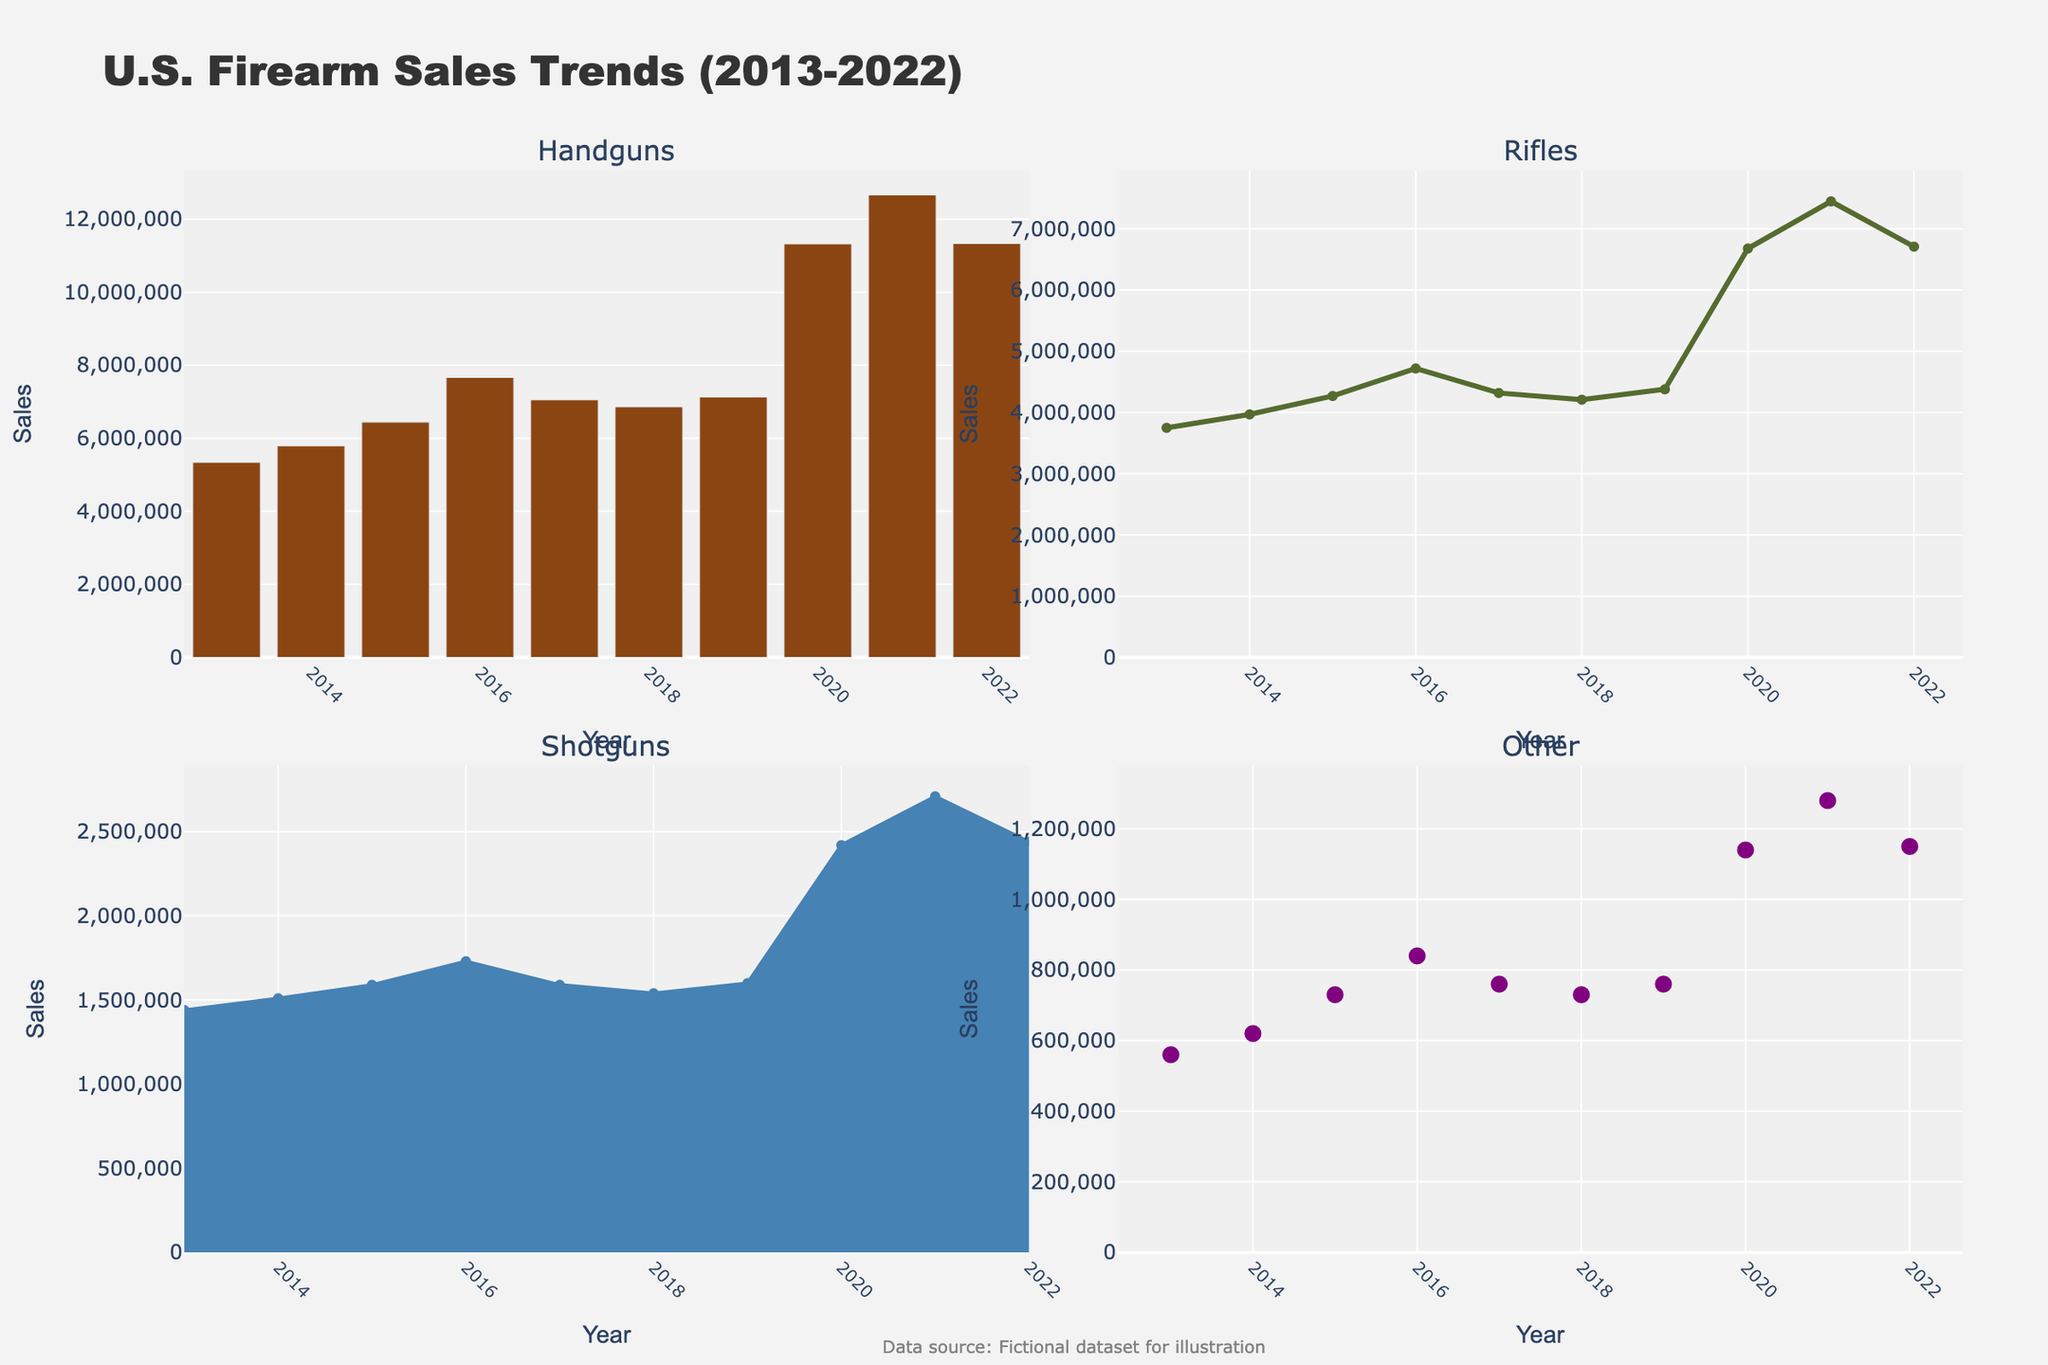What is the highest number of Mountain Bikes sold in any given year? Looking at the Mountain Bikes subplot, we see that the maximum sales occur in 2020, with 4500 units sold.
Answer: 4500 What trend can be observed in the sales of City Bikes from 1990 to 2020? Observing the City Bikes subplot, sales show a steady increase over the years from 1990 (3500) to 2020 (6500). The trend clearly indicates growing popularity of City Bikes.
Answer: Steady increase Which type of bike had the highest sales in the year 1995? In the year 1995, the sales data for Road, Mountain, and City Bikes are 1500, 1800, and 4000 respectively. Clearly, City Bikes had the highest sales.
Answer: City Bikes How do Road Bikes sales in 2020 compare to their sales in 1990? In 2020, Road Bikes sales are 1000, while in 1990, it was 1200. Therefore, Road Bikes sales decreased over this period.
Answer: Decreased What is the average sales of Mountain Bikes between 1990 and 2020? The sales for Mountain Bikes across the years are: 800, 1800, 2500, 3200, 3800, 4200, and 4500. Summing these gives 20800. Dividing by 7 (the number of data points) gives an average of 2971.43.
Answer: 2971.43 How do the sales trends of Road Bikes and Mountain Bikes compare over the three decades? Road Bikes sales show a general decline from 1990 (1200) to 2020 (1000). In contrast, Mountain Bikes sales show a steady increase from 1990 (800) to 2020 (4500). This reflects growing popularity of Mountain Bikes over time compared to Road Bikes.
Answer: Road Bikes declined, Mountain Bikes increased In which year did City Bikes see a sales pass of the 5000 units mark? Observing the City Bikes subplot, sales hit 5000 units in the year 2005 and continued to rise afterward.
Answer: 2005 What is the difference in Road Bikes sales between the peak year and the lowest year? The peak year for Road Bikes is 2000 with 1800 units sold, and the lowest year is 2020 with 1000 units sold. The difference is 1800 - 100 = 800.
Answer: 800 What's the relative growth in City Bikes sales from 1990 to 2020? In 1990, City Bikes sales were 3500, and in 2020, they were 6500. The growth is 6500 - 3500 = 3000, which is relative to the original 3500, giving a growth ratio of 3000/3500 ≈ 0.857 or 85.7%.
Answer: 85.7% How has the year-on-year growth rate of Mountain Bikes sales changed from 1990 to 1995 compared to 2015 to 2020? For 1990 to 1995, growth is (1800 - 800) / 5 = 200/year. For 2015 to 2020, growth is (4500 - 4200) / 5 = 60/year. The earlier period shows a faster growth rate compared to the latter.
Answer: Faster growth initially 